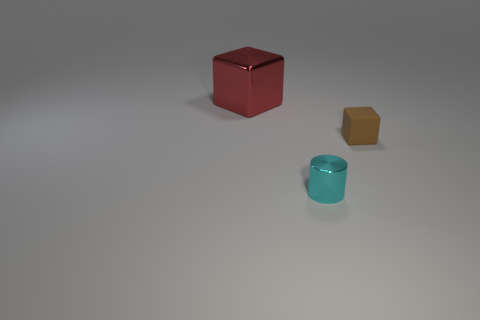Add 1 large blue rubber cylinders. How many objects exist? 4 Subtract all cylinders. How many objects are left? 2 Add 1 cyan things. How many cyan things exist? 2 Subtract 1 brown blocks. How many objects are left? 2 Subtract all purple metallic blocks. Subtract all small things. How many objects are left? 1 Add 3 tiny cyan things. How many tiny cyan things are left? 4 